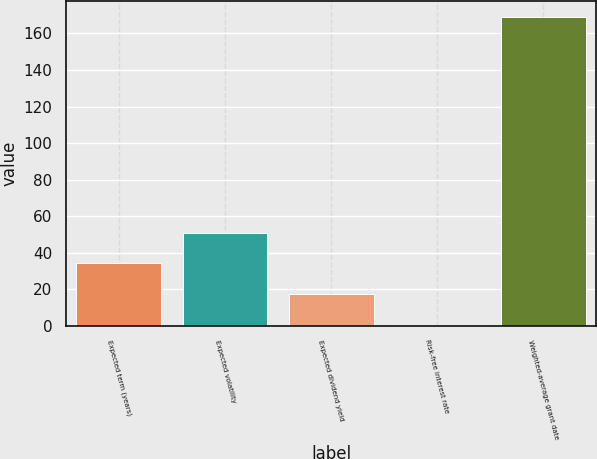Convert chart to OTSL. <chart><loc_0><loc_0><loc_500><loc_500><bar_chart><fcel>Expected term (years)<fcel>Expected volatility<fcel>Expected dividend yield<fcel>Risk-free interest rate<fcel>Weighted-average grant date<nl><fcel>34.14<fcel>51.01<fcel>17.27<fcel>0.4<fcel>169.14<nl></chart> 